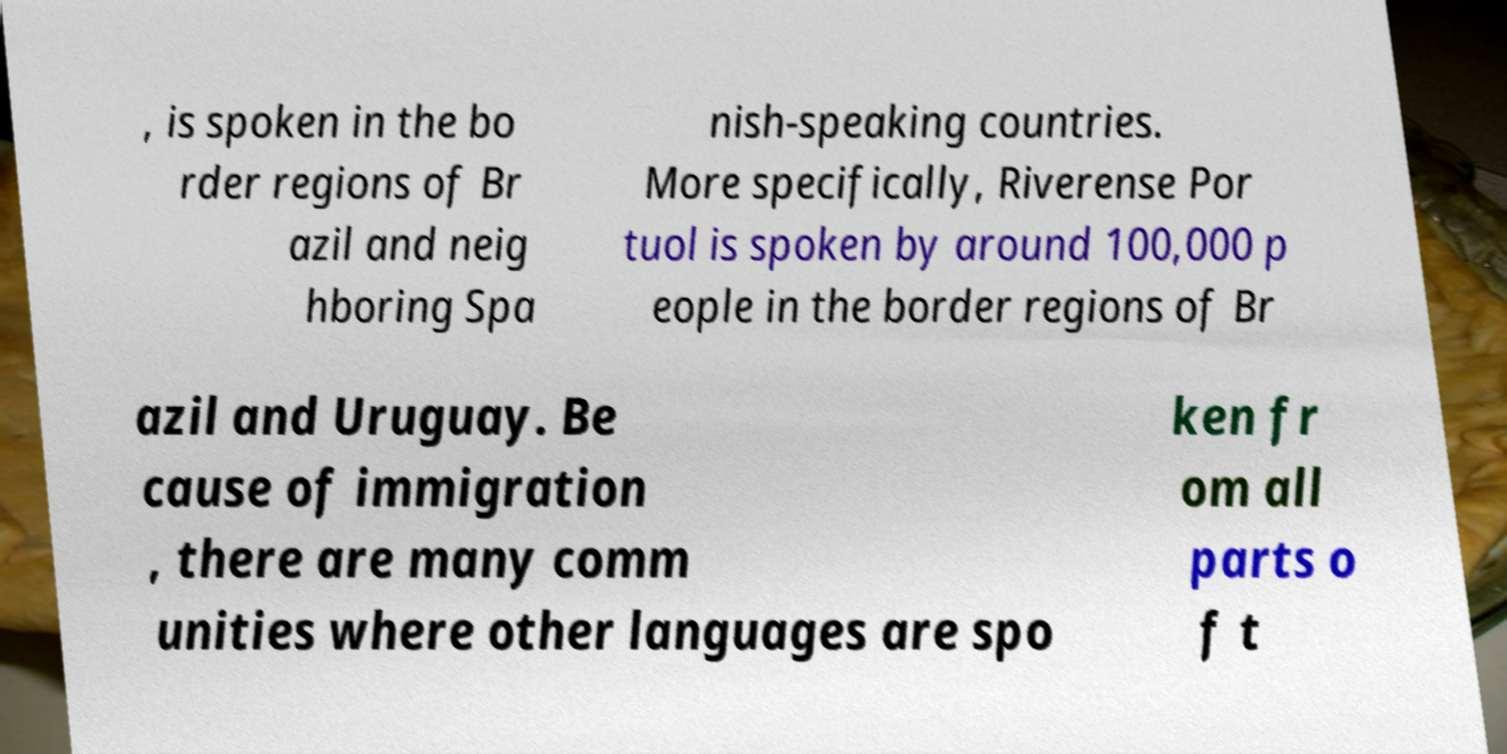Please identify and transcribe the text found in this image. , is spoken in the bo rder regions of Br azil and neig hboring Spa nish-speaking countries. More specifically, Riverense Por tuol is spoken by around 100,000 p eople in the border regions of Br azil and Uruguay. Be cause of immigration , there are many comm unities where other languages are spo ken fr om all parts o f t 